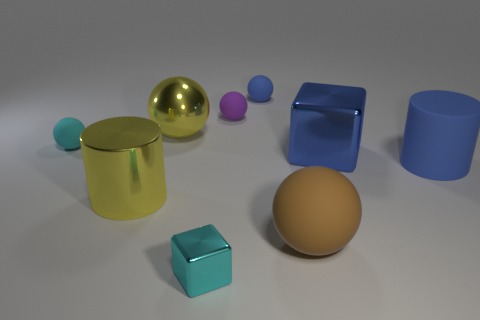Subtract all tiny blue matte spheres. How many spheres are left? 4 Add 1 gray shiny blocks. How many objects exist? 10 Subtract all blue cubes. How many cubes are left? 1 Subtract 0 green cylinders. How many objects are left? 9 Subtract all cubes. How many objects are left? 7 Subtract 2 cylinders. How many cylinders are left? 0 Subtract all brown cubes. Subtract all red balls. How many cubes are left? 2 Subtract all gray balls. How many blue cylinders are left? 1 Subtract all large gray matte cylinders. Subtract all big brown spheres. How many objects are left? 8 Add 4 small cyan shiny cubes. How many small cyan shiny cubes are left? 5 